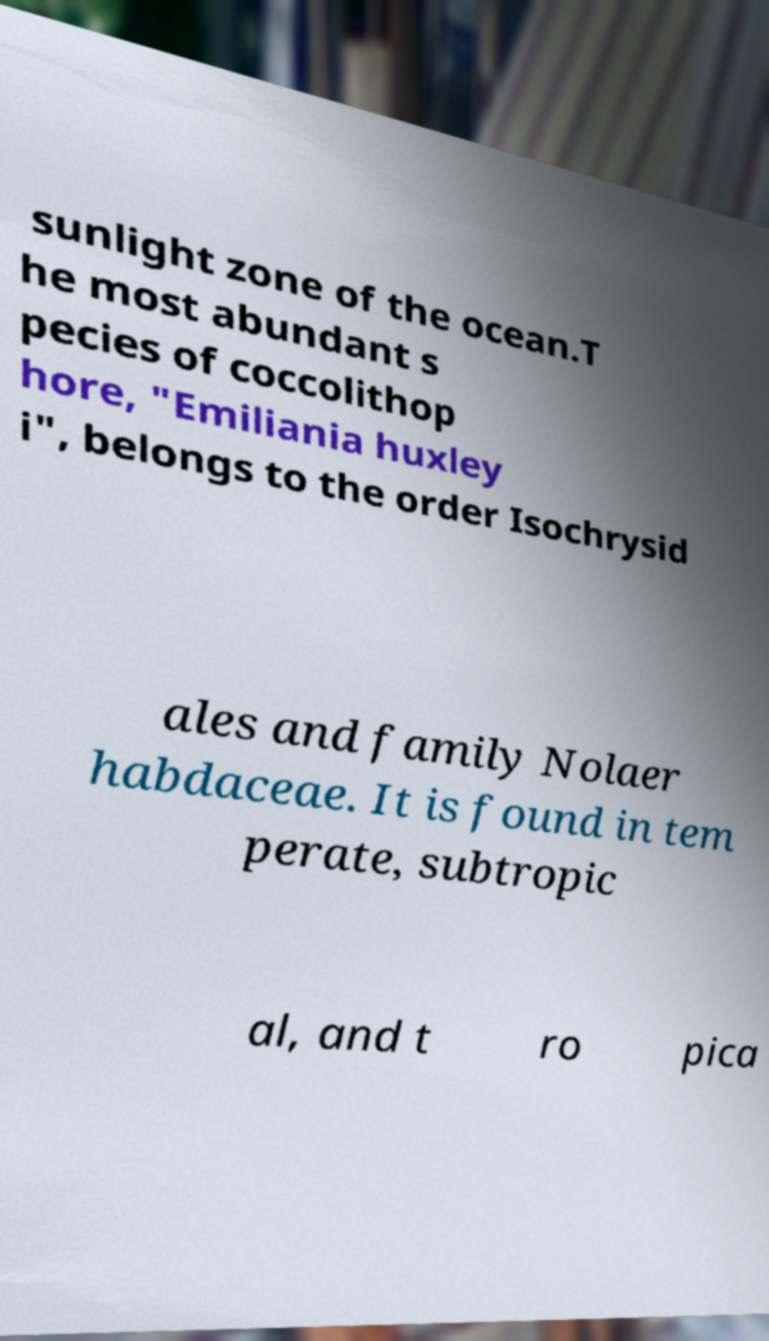Please identify and transcribe the text found in this image. sunlight zone of the ocean.T he most abundant s pecies of coccolithop hore, "Emiliania huxley i", belongs to the order Isochrysid ales and family Nolaer habdaceae. It is found in tem perate, subtropic al, and t ro pica 